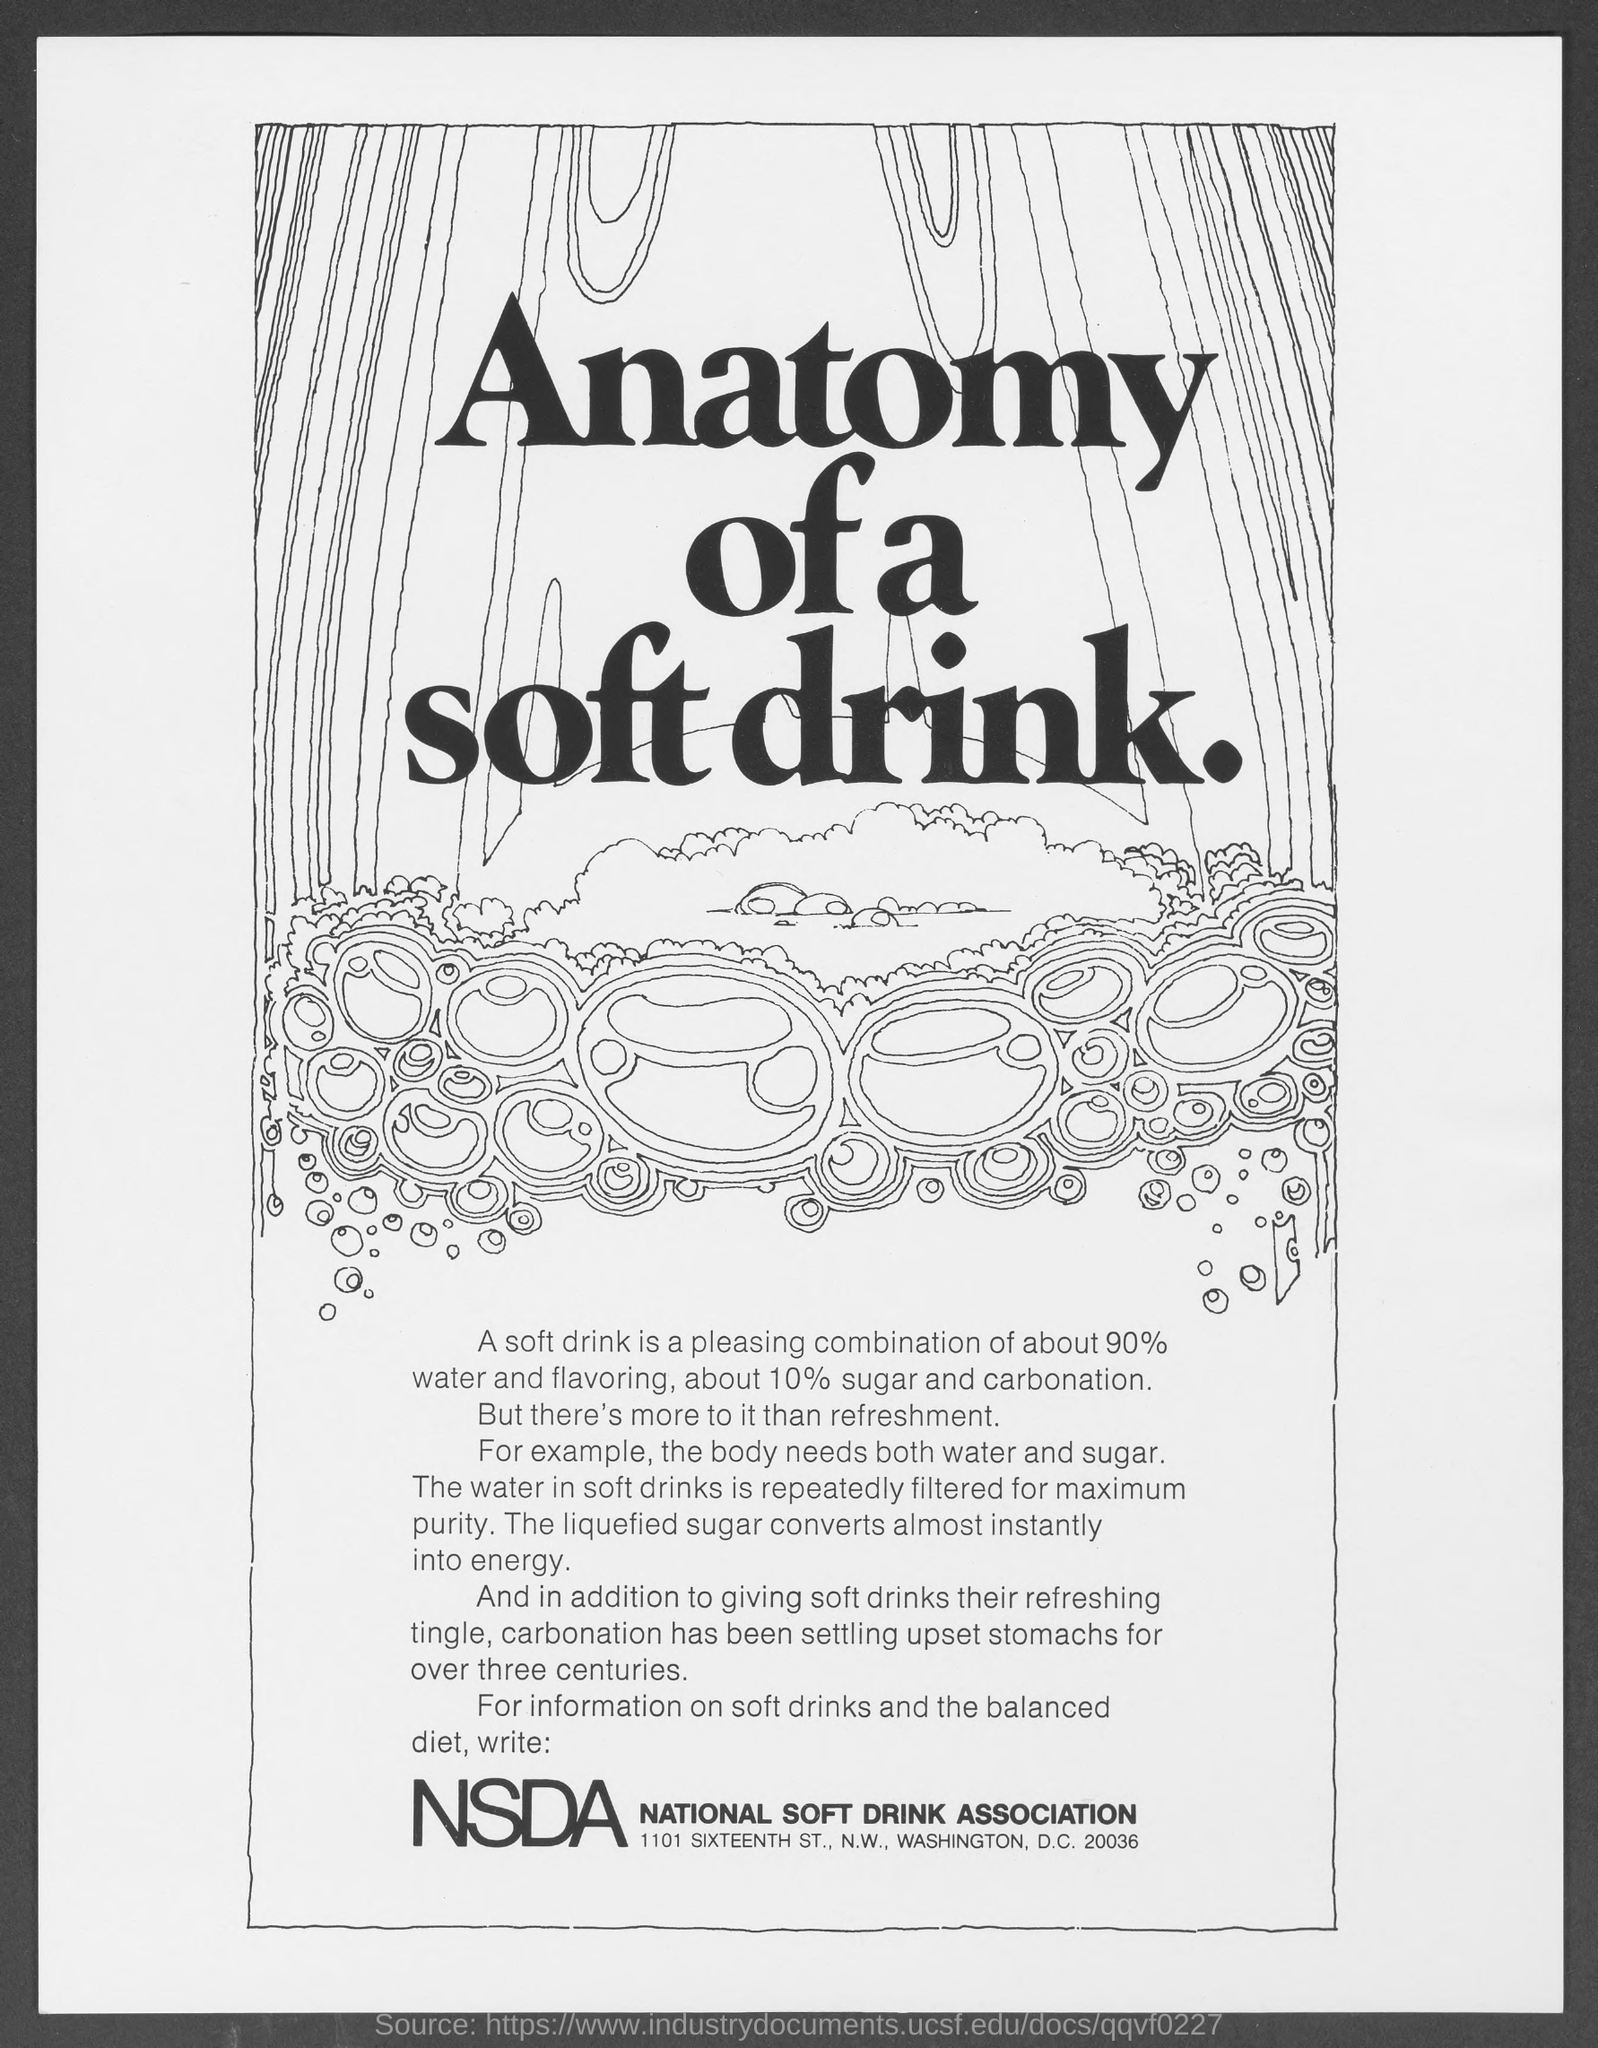What does ncda stand for ?
Make the answer very short. National Soft Drink Association. 